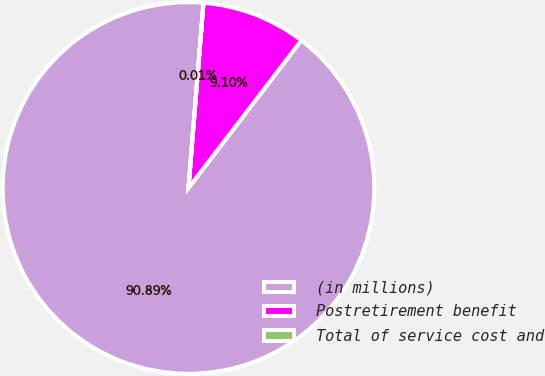<chart> <loc_0><loc_0><loc_500><loc_500><pie_chart><fcel>(in millions)<fcel>Postretirement benefit<fcel>Total of service cost and<nl><fcel>90.89%<fcel>9.1%<fcel>0.01%<nl></chart> 